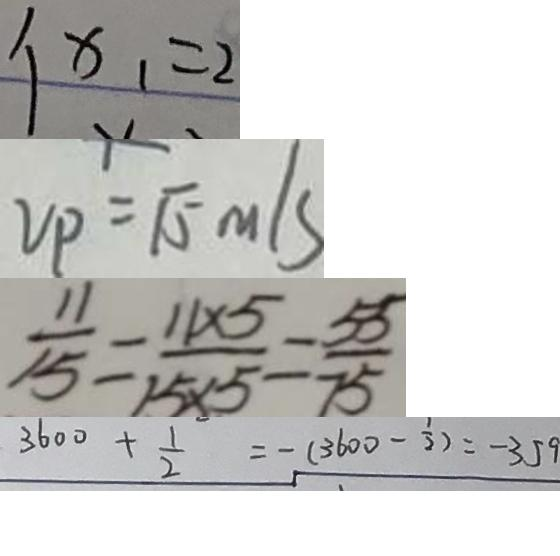<formula> <loc_0><loc_0><loc_500><loc_500>x _ { 1 } = 2 
 V _ { P } = \sqrt { 5 } m / s 
 \frac { 1 1 } { 1 5 } = \frac { 1 1 \times 5 } { 1 5 \times 5 } = \frac { 5 5 } { 7 5 } 
 3 6 0 0 + \frac { 1 } { 2 } = - ( 3 6 0 0 - \frac { 1 } { 2 } ) = - 3 5 9</formula> 